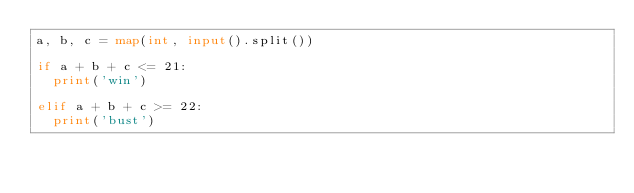<code> <loc_0><loc_0><loc_500><loc_500><_Python_>a, b, c = map(int, input().split())

if a + b + c <= 21:
  print('win')

elif a + b + c >= 22:
  print('bust')</code> 